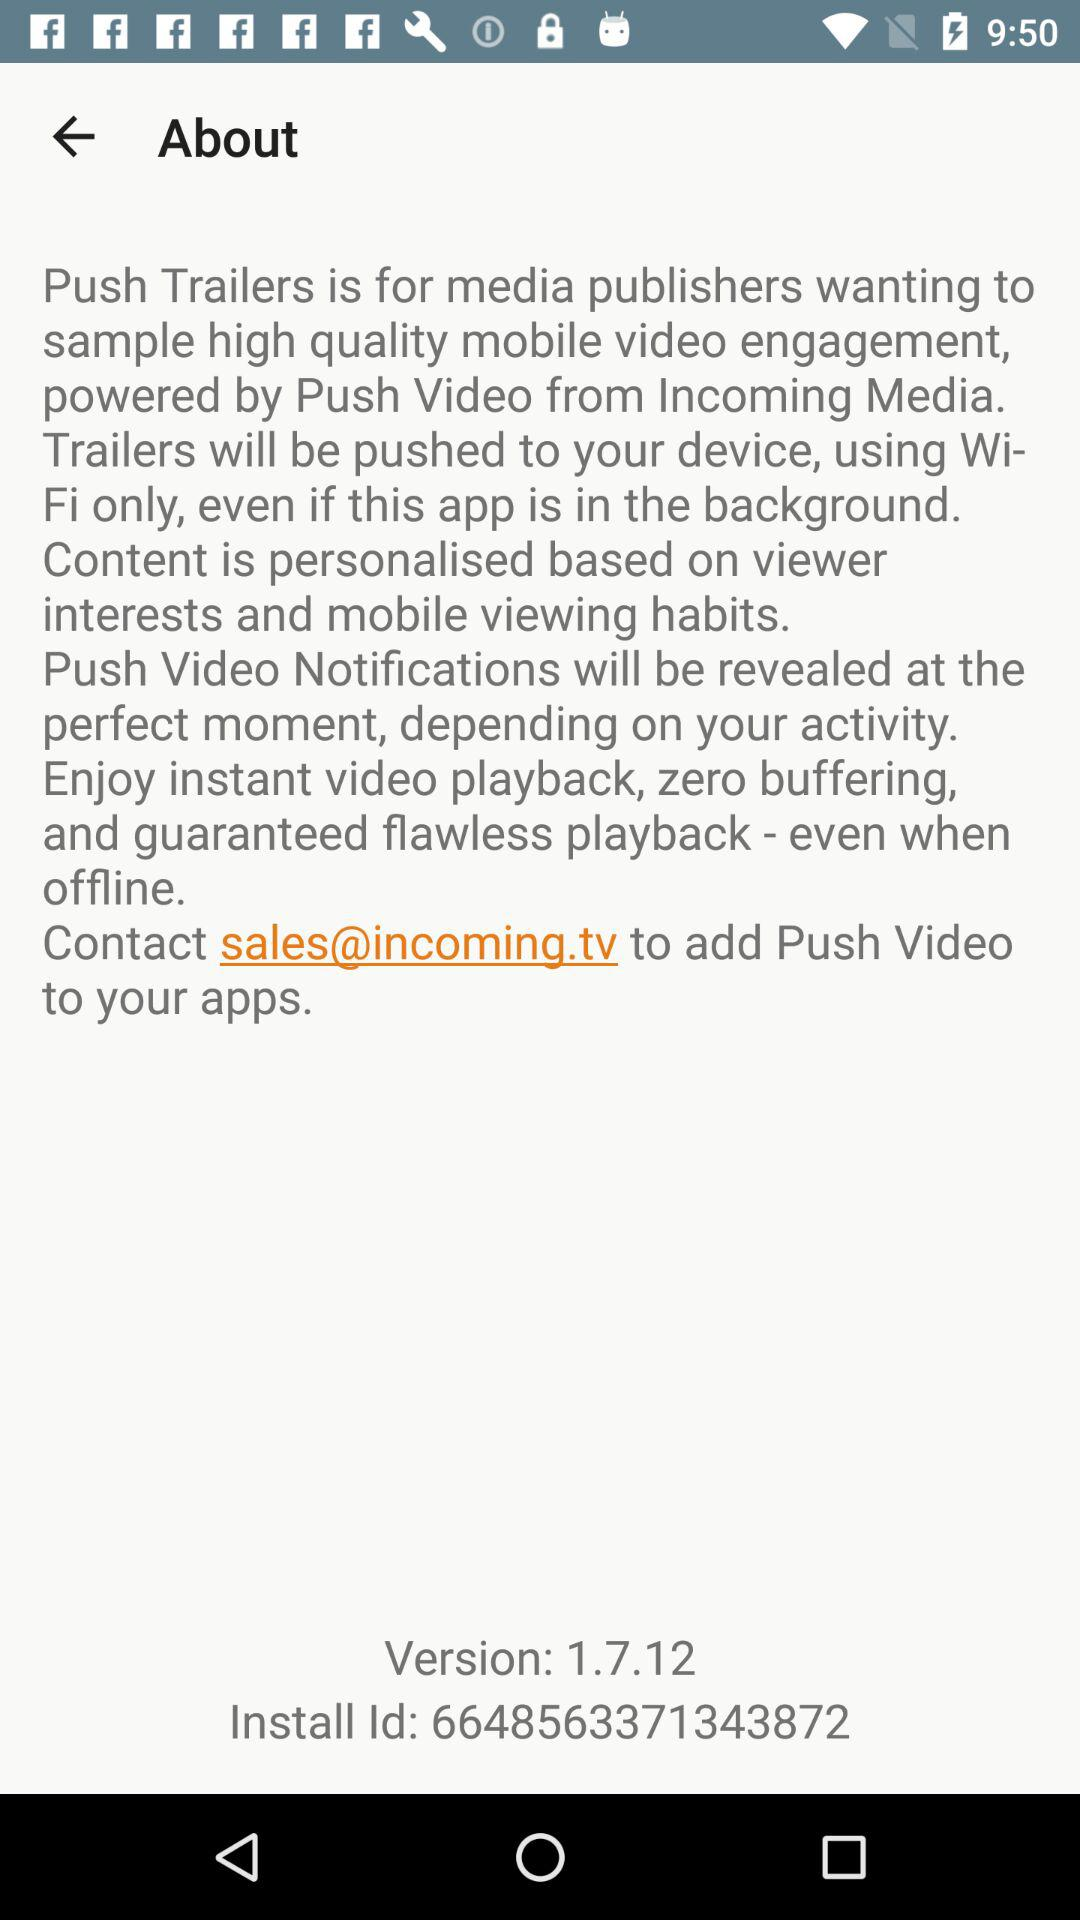How many versions of the app are available?
Answer the question using a single word or phrase. 1.7.12 